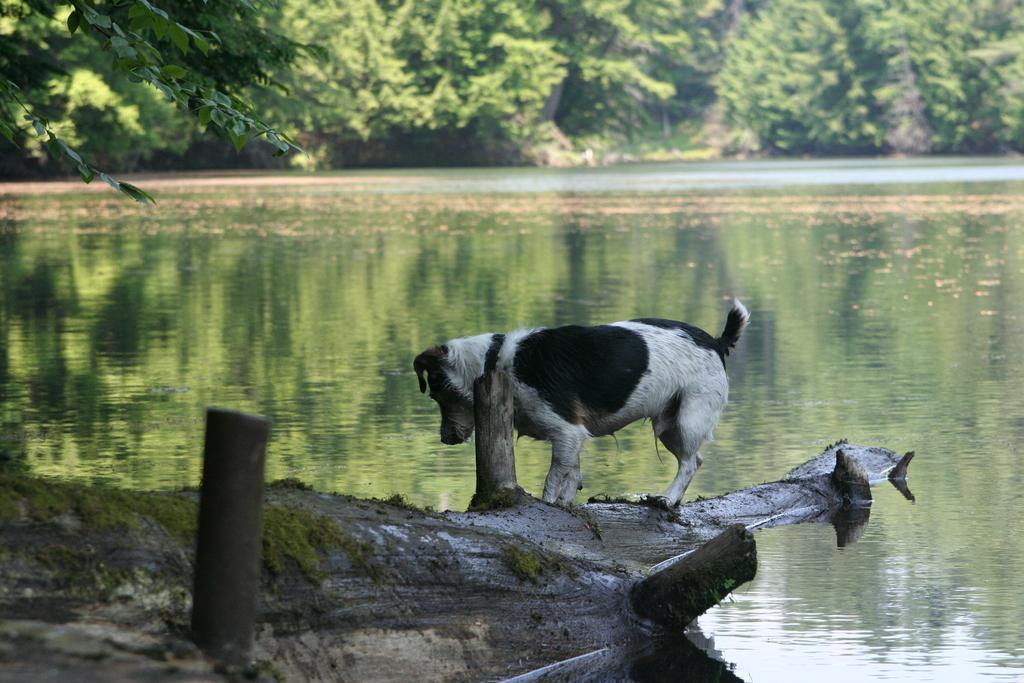How would you summarize this image in a sentence or two? In this image I can see the lake, in front of the lake I can see a dog, two poles at the bottom, at the top I can see trees. 